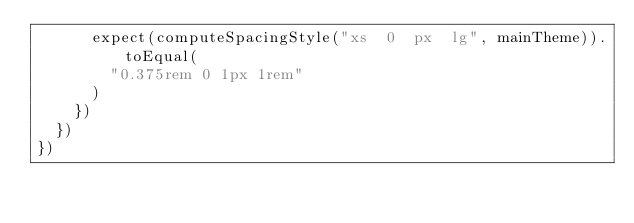Convert code to text. <code><loc_0><loc_0><loc_500><loc_500><_TypeScript_>      expect(computeSpacingStyle("xs  0  px  lg", mainTheme)).toEqual(
        "0.375rem 0 1px 1rem"
      )
    })
  })
})
</code> 